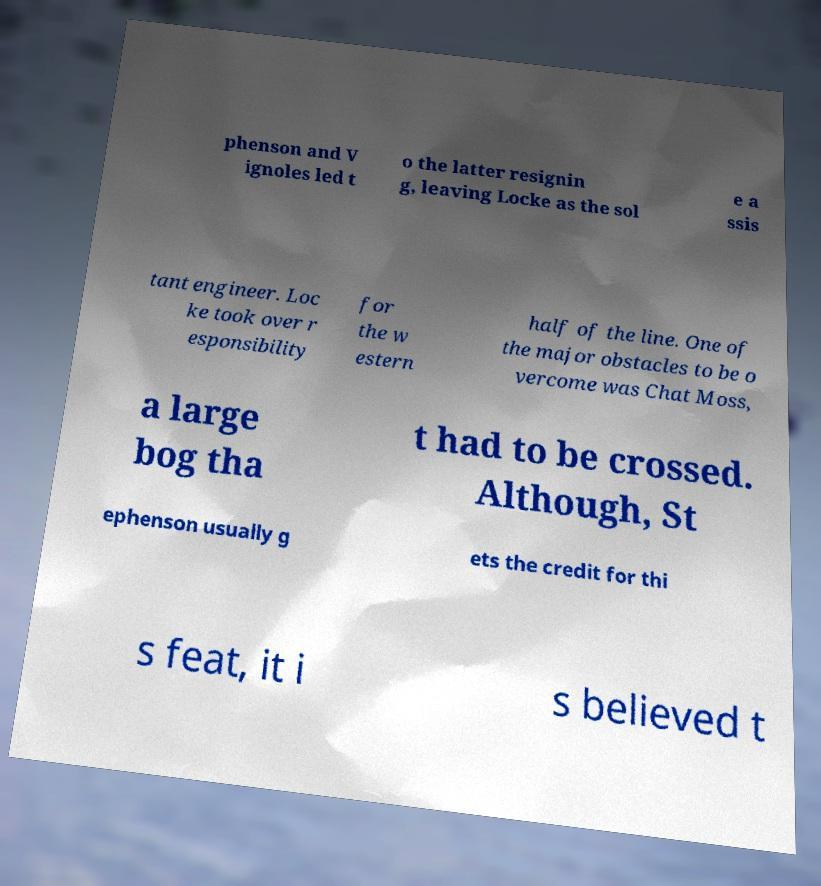I need the written content from this picture converted into text. Can you do that? phenson and V ignoles led t o the latter resignin g, leaving Locke as the sol e a ssis tant engineer. Loc ke took over r esponsibility for the w estern half of the line. One of the major obstacles to be o vercome was Chat Moss, a large bog tha t had to be crossed. Although, St ephenson usually g ets the credit for thi s feat, it i s believed t 